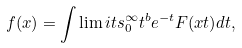<formula> <loc_0><loc_0><loc_500><loc_500>f ( x ) = \int \lim i t s _ { 0 } ^ { \infty } t ^ { b } e ^ { - t } F ( x t ) d t , \ \</formula> 